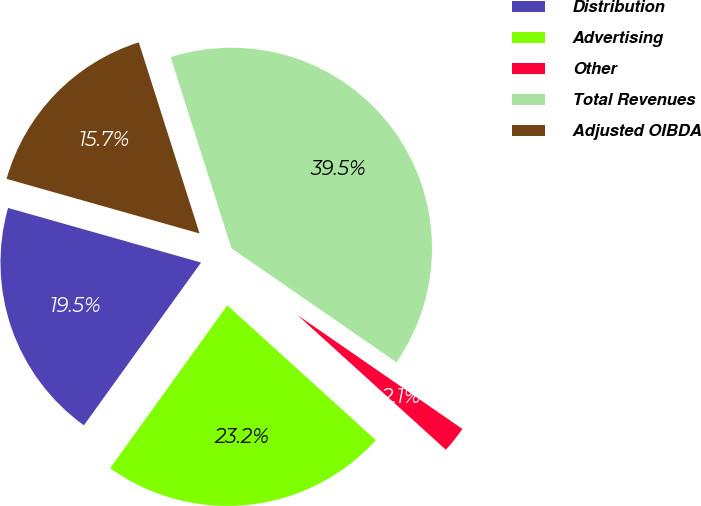<chart> <loc_0><loc_0><loc_500><loc_500><pie_chart><fcel>Distribution<fcel>Advertising<fcel>Other<fcel>Total Revenues<fcel>Adjusted OIBDA<nl><fcel>19.46%<fcel>23.2%<fcel>2.11%<fcel>39.52%<fcel>15.71%<nl></chart> 